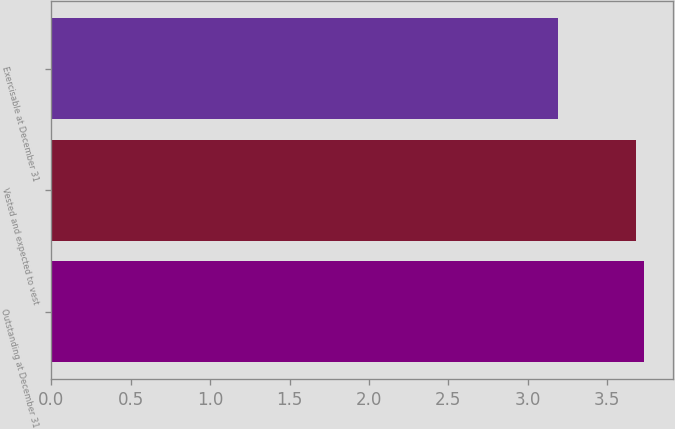<chart> <loc_0><loc_0><loc_500><loc_500><bar_chart><fcel>Outstanding at December 31<fcel>Vested and expected to vest<fcel>Exercisable at December 31<nl><fcel>3.73<fcel>3.68<fcel>3.19<nl></chart> 